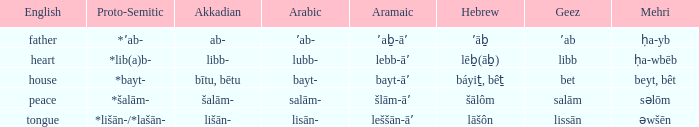If the proto-semitic is *bayt-, what are the geez counterparts? Bet. 